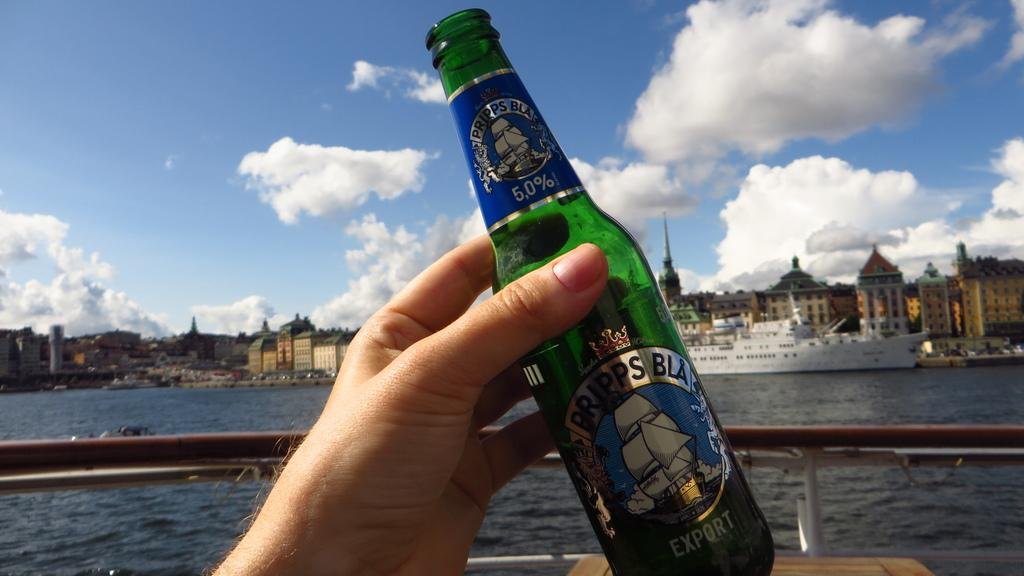Provide a one-sentence caption for the provided image. A bottle of beer which the brand is Pripps Bla. 